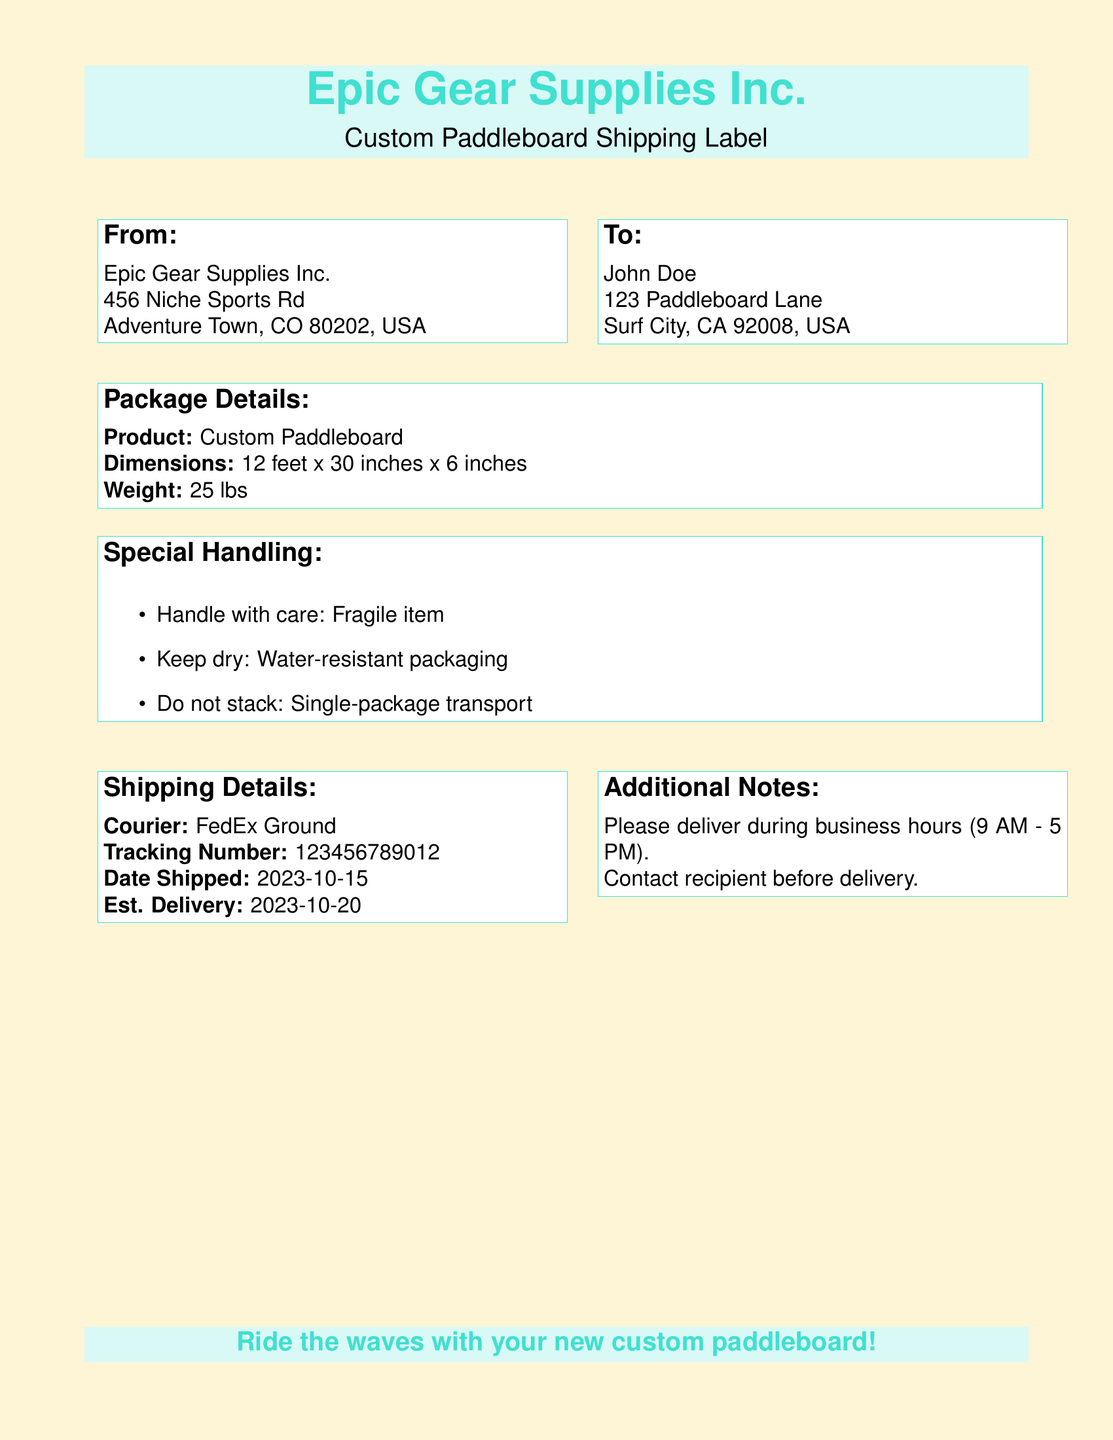What is the product being shipped? The document specifies that the product being shipped is a "Custom Paddleboard."
Answer: Custom Paddleboard What are the dimensions of the paddleboard? The dimensions of the paddleboard are provided in the package details section as "12 feet x 30 inches x 6 inches."
Answer: 12 feet x 30 inches x 6 inches What is the weight of the package? The document lists the weight of the package in the package details as "25 lbs."
Answer: 25 lbs What courier is being used for shipping? The shipping details section identifies the courier service as "FedEx Ground."
Answer: FedEx Ground What is the estimated delivery date? The estimated delivery date can be found in the shipping details as "2023-10-20."
Answer: 2023-10-20 What special instruction is given for handling the item? The special handling instructions indicate that the item is a "Fragile item."
Answer: Fragile item How should the package be transported? The handling instructions state to "Do not stack: Single-package transport."
Answer: Do not stack: Single-package transport When was the package shipped? The document notes that the package was shipped on "2023-10-15."
Answer: 2023-10-15 Who is the recipient of the paddleboard? The recipient's name is provided in the "To" section as "John Doe."
Answer: John Doe 